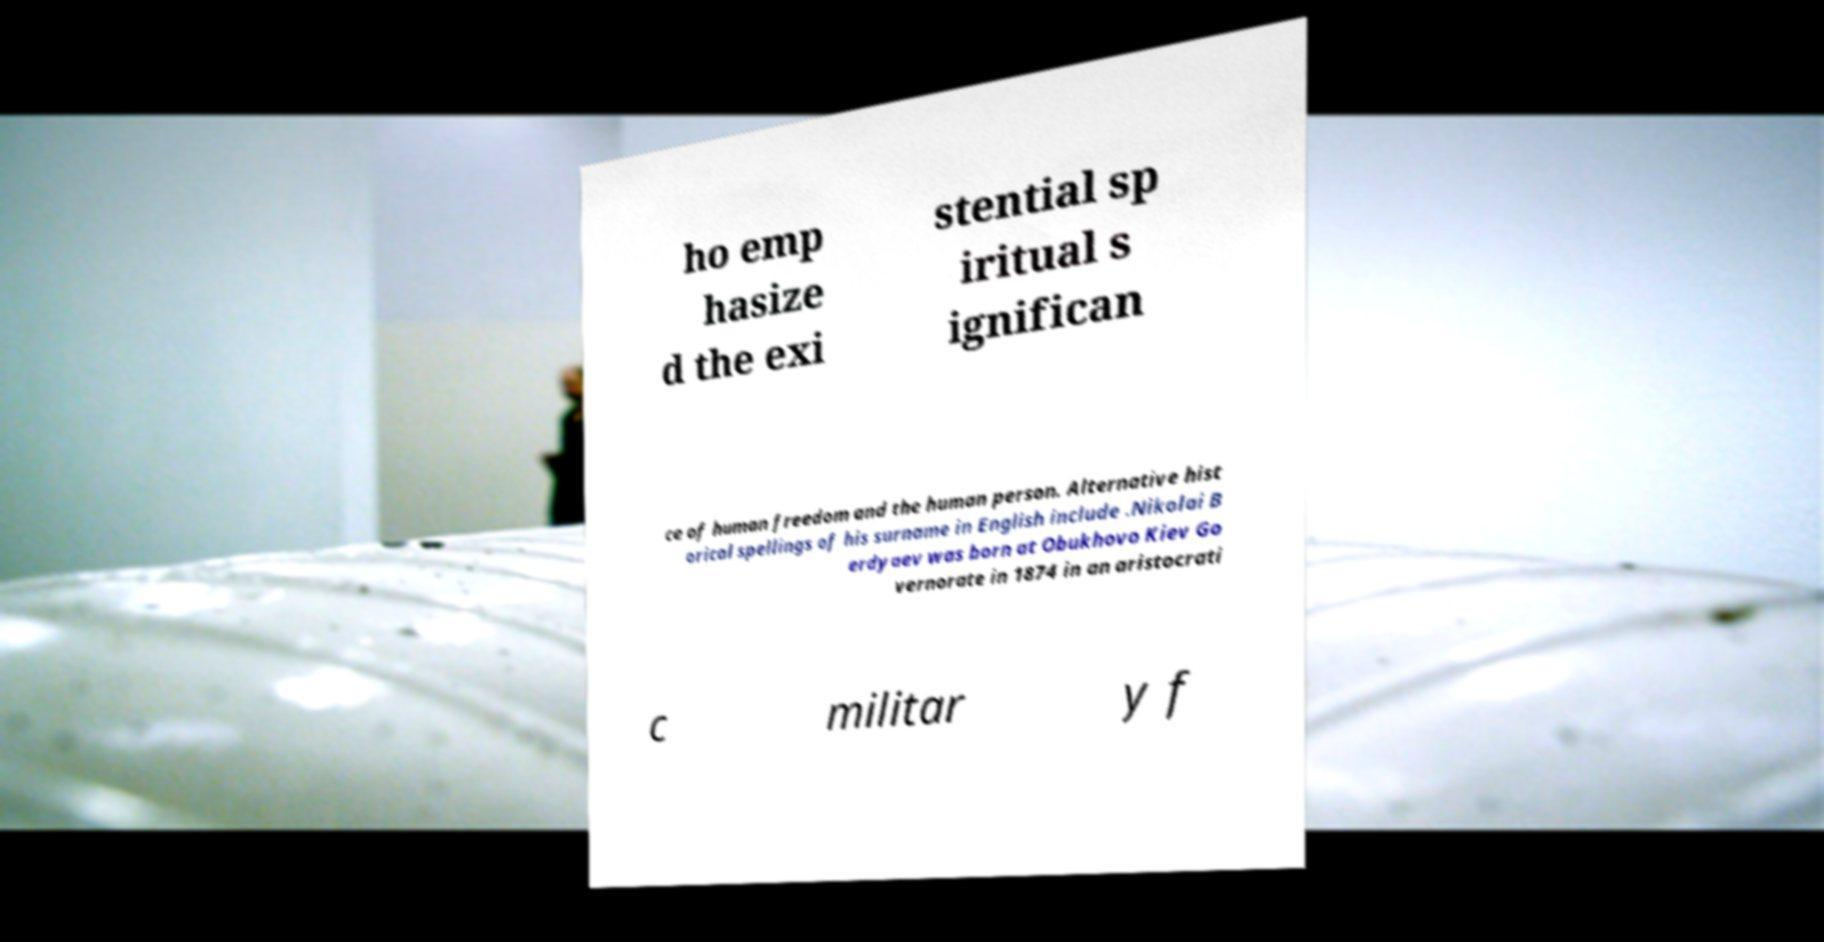For documentation purposes, I need the text within this image transcribed. Could you provide that? ho emp hasize d the exi stential sp iritual s ignifican ce of human freedom and the human person. Alternative hist orical spellings of his surname in English include .Nikolai B erdyaev was born at Obukhovo Kiev Go vernorate in 1874 in an aristocrati c militar y f 